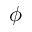<formula> <loc_0><loc_0><loc_500><loc_500>\phi</formula> 